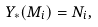<formula> <loc_0><loc_0><loc_500><loc_500>Y _ { \ast } ( M _ { i } ) = N _ { i } ,</formula> 